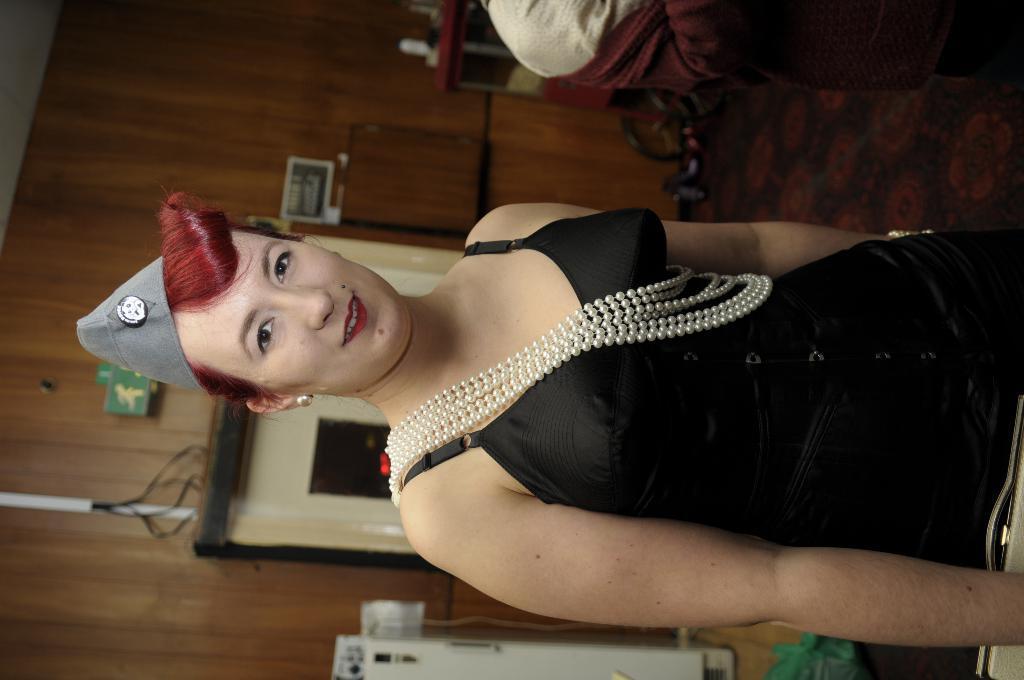Can you describe this image briefly? In this picture we can see a woman wore a cap, smiling and in the background we can see the wall, cables and some objects. 